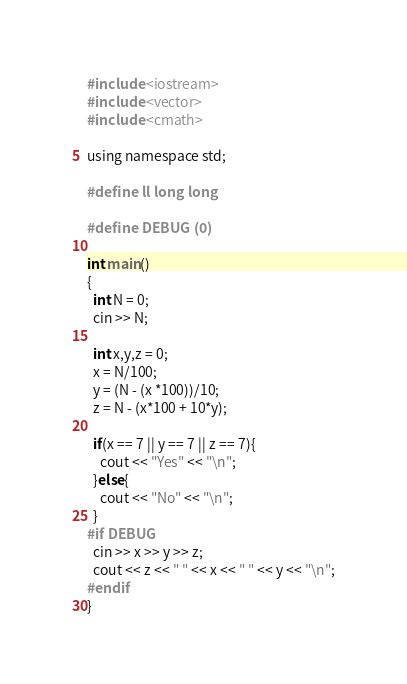Convert code to text. <code><loc_0><loc_0><loc_500><loc_500><_C_>#include <iostream>
#include <vector>
#include <cmath>

using namespace std;

#define ll long long

#define DEBUG (0)

int main()
{
  int N = 0;
  cin >> N;

  int x,y,z = 0;
  x = N/100;
  y = (N - (x *100))/10;
  z = N - (x*100 + 10*y);

  if(x == 7 || y == 7 || z == 7){
    cout << "Yes" << "\n";
  }else{
    cout << "No" << "\n";
  }
#if DEBUG
  cin >> x >> y >> z;
  cout << z << " " << x << " " << y << "\n";
#endif
}
</code> 